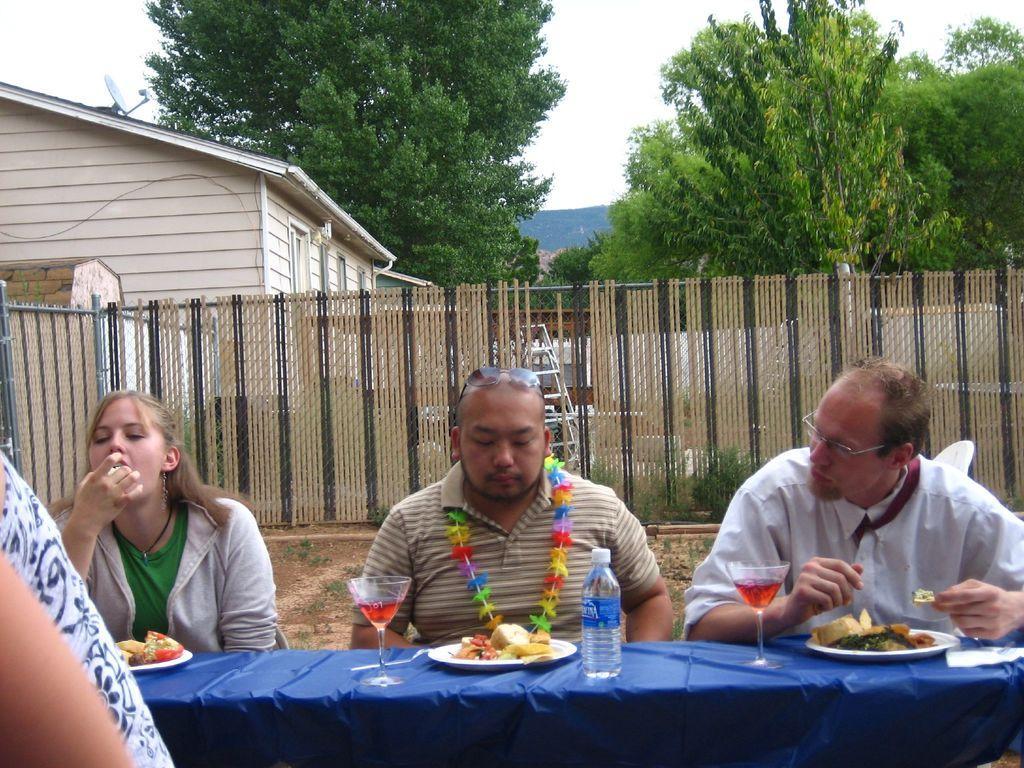Describe this image in one or two sentences. As we can see in the image there are three people sitting on chairs, fence, house, trees, sky and table. On table there is a blue color cloth, plates, bottle, glass and dishes. 